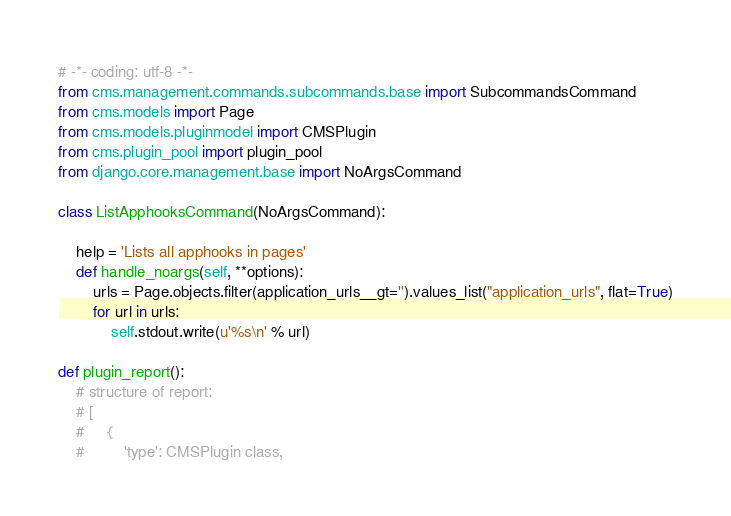Convert code to text. <code><loc_0><loc_0><loc_500><loc_500><_Python_># -*- coding: utf-8 -*-
from cms.management.commands.subcommands.base import SubcommandsCommand
from cms.models import Page
from cms.models.pluginmodel import CMSPlugin
from cms.plugin_pool import plugin_pool
from django.core.management.base import NoArgsCommand

class ListApphooksCommand(NoArgsCommand):

    help = 'Lists all apphooks in pages'
    def handle_noargs(self, **options):
        urls = Page.objects.filter(application_urls__gt='').values_list("application_urls", flat=True)
        for url in urls:
            self.stdout.write(u'%s\n' % url)

def plugin_report():
    # structure of report:
    # [
    #     {
    #         'type': CMSPlugin class,</code> 